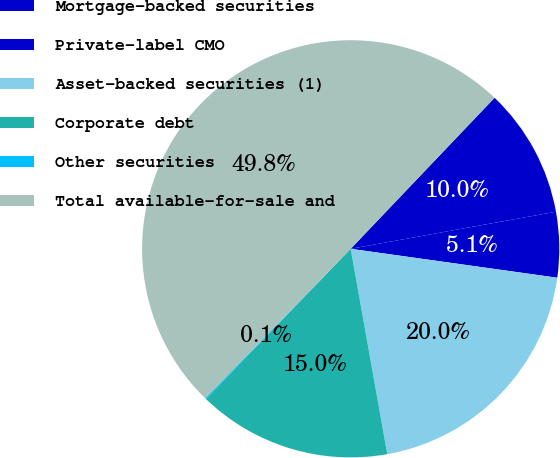Convert chart. <chart><loc_0><loc_0><loc_500><loc_500><pie_chart><fcel>Mortgage-backed securities<fcel>Private-label CMO<fcel>Asset-backed securities (1)<fcel>Corporate debt<fcel>Other securities<fcel>Total available-for-sale and<nl><fcel>10.04%<fcel>5.06%<fcel>19.98%<fcel>15.01%<fcel>0.09%<fcel>49.82%<nl></chart> 